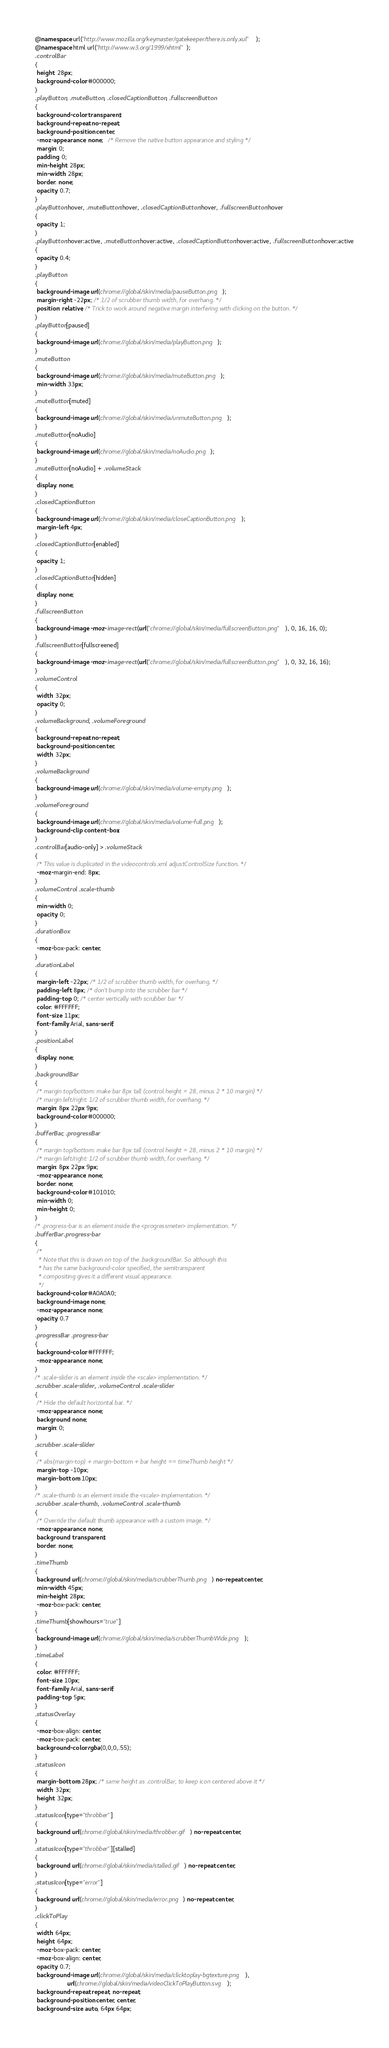<code> <loc_0><loc_0><loc_500><loc_500><_CSS_>@namespace url("http://www.mozilla.org/keymaster/gatekeeper/there.is.only.xul");
@namespace html url("http://www.w3.org/1999/xhtml");
.controlBar
{
 height: 28px;
 background-color: #000000;
}
.playButton, .muteButton, .closedCaptionButton, .fullscreenButton
{
 background-color: transparent;
 background-repeat: no-repeat;
 background-position: center;
 -moz-appearance: none;   /* Remove the native button appearance and styling */
 margin: 0;
 padding: 0;
 min-height: 28px;
 min-width: 28px;
 border: none;
 opacity: 0.7;
}
.playButton:hover, .muteButton:hover, .closedCaptionButton:hover, .fullscreenButton:hover
{
 opacity: 1;
}
.playButton:hover:active, .muteButton:hover:active, .closedCaptionButton:hover:active, .fullscreenButton:hover:active
{
 opacity: 0.4;
}
.playButton
{
 background-image: url(chrome://global/skin/media/pauseButton.png);
 margin-right: -22px; /* 1/2 of scrubber thumb width, for overhang. */
 position: relative; /* Trick to work around negative margin interfering with clicking on the button. */
}
.playButton[paused]
{
 background-image: url(chrome://global/skin/media/playButton.png);
}
.muteButton
{
 background-image: url(chrome://global/skin/media/muteButton.png);
 min-width: 33px;
}
.muteButton[muted]
{
 background-image: url(chrome://global/skin/media/unmuteButton.png);
}
.muteButton[noAudio]
{
 background-image: url(chrome://global/skin/media/noAudio.png);
}
.muteButton[noAudio] + .volumeStack
{
 display: none;
}
.closedCaptionButton
{
 background-image: url(chrome://global/skin/media/closeCaptionButton.png);
 margin-left: 4px;
}
.closedCaptionButton[enabled]
{
 opacity: 1;
}
.closedCaptionButton[hidden]
{
 display: none;
}
.fullscreenButton
{
 background-image: -moz-image-rect(url("chrome://global/skin/media/fullscreenButton.png"), 0, 16, 16, 0);
}
.fullscreenButton[fullscreened]
{
 background-image: -moz-image-rect(url("chrome://global/skin/media/fullscreenButton.png"), 0, 32, 16, 16);
}
.volumeControl
{
 width: 32px;
 opacity: 0;
}
.volumeBackground, .volumeForeground
{
 background-repeat: no-repeat;
 background-position: center;
 width: 32px;
}
.volumeBackground
{
 background-image: url(chrome://global/skin/media/volume-empty.png);
}
.volumeForeground
{
 background-image: url(chrome://global/skin/media/volume-full.png);
 background-clip: content-box;
}
.controlBar[audio-only] > .volumeStack
{
 /* This value is duplicated in the videocontrols.xml adjustControlSize function. */
 -moz-margin-end: 8px;
}
.volumeControl .scale-thumb
{
 min-width: 0;
 opacity: 0;
}
.durationBox
{
 -moz-box-pack: center;
}
.durationLabel
{
 margin-left: -22px; /* 1/2 of scrubber thumb width, for overhang. */
 padding-left: 8px; /* don't bump into the scrubber bar */
 padding-top: 0; /* center vertically with scrubber bar */
 color: #FFFFFF;
 font-size: 11px;
 font-family: Arial, sans-serif;
}
.positionLabel
{
 display: none;
}
.backgroundBar
{
 /* margin top/bottom: make bar 8px tall (control height = 28, minus 2 * 10 margin) */
 /* margin left/right: 1/2 of scrubber thumb width, for overhang. */
 margin: 8px 22px 9px;
 background-color: #000000;
}
.bufferBar, .progressBar
{
 /* margin top/bottom: make bar 8px tall (control height = 28, minus 2 * 10 margin) */
 /* margin left/right: 1/2 of scrubber thumb width, for overhang. */
 margin: 8px 22px 9px;
 -moz-appearance: none;
 border: none;
 background-color: #101010;
 min-width: 0;
 min-height: 0;
}
/* .progress-bar is an element inside the <progressmeter> implementation. */
.bufferBar .progress-bar
{
 /*
  * Note that this is drawn on top of the .backgroundBar. So although this
  * has the same background-color specified, the semitransparent
  * compositing gives it a different visual appearance.
  */
 background-color: #A0A0A0;
 background-image: none;
 -moz-appearance: none;
 opacity: 0.7
}
.progressBar .progress-bar
{
 background-color: #FFFFFF;
 -moz-appearance: none;
}
/* .scale-slider is an element inside the <scale> implementation. */
.scrubber .scale-slider, .volumeControl .scale-slider
{
 /* Hide the default horizontal bar. */
 -moz-appearance: none;
 background: none;
 margin: 0;
}
.scrubber .scale-slider
{
 /* abs(margin-top) + margin-bottom + bar height == timeThumb height */
 margin-top: -10px;
 margin-bottom: 10px;
}
/* .scale-thumb is an element inside the <scale> implementation. */
.scrubber .scale-thumb, .volumeControl .scale-thumb
{
 /* Override the default thumb appearance with a custom image. */
 -moz-appearance: none;
 background: transparent;
 border: none;
}
.timeThumb
{
 background: url(chrome://global/skin/media/scrubberThumb.png) no-repeat center;
 min-width: 45px;
 min-height: 28px;
 -moz-box-pack: center;
}
.timeThumb[showhours="true"]
{
 background-image: url(chrome://global/skin/media/scrubberThumbWide.png);
}
.timeLabel
{
 color: #FFFFFF;
 font-size: 10px;
 font-family: Arial, sans-serif;
 padding-top: 5px;
}
.statusOverlay
{
 -moz-box-align: center;
 -moz-box-pack: center;
 background-color: rgba(0,0,0,.55);
}
.statusIcon
{
 margin-bottom: 28px; /* same height as .controlBar, to keep icon centered above it */
 width: 32px;
 height: 32px;
}
.statusIcon[type="throbber"]
{
 background: url(chrome://global/skin/media/throbber.gif) no-repeat center;
}
.statusIcon[type="throbber"][stalled]
{
 background: url(chrome://global/skin/media/stalled.gif) no-repeat center;
}
.statusIcon[type="error"]
{
 background: url(chrome://global/skin/media/error.png) no-repeat center;
}
.clickToPlay
{
 width: 64px;
 height: 64px;
 -moz-box-pack: center;
 -moz-box-align: center;
 opacity: 0.7;
 background-image: url(chrome://global/skin/media/clicktoplay-bgtexture.png),
                   url(chrome://global/skin/media/videoClickToPlayButton.svg);
 background-repeat: repeat, no-repeat;
 background-position: center, center;
 background-size: auto, 64px 64px;</code> 